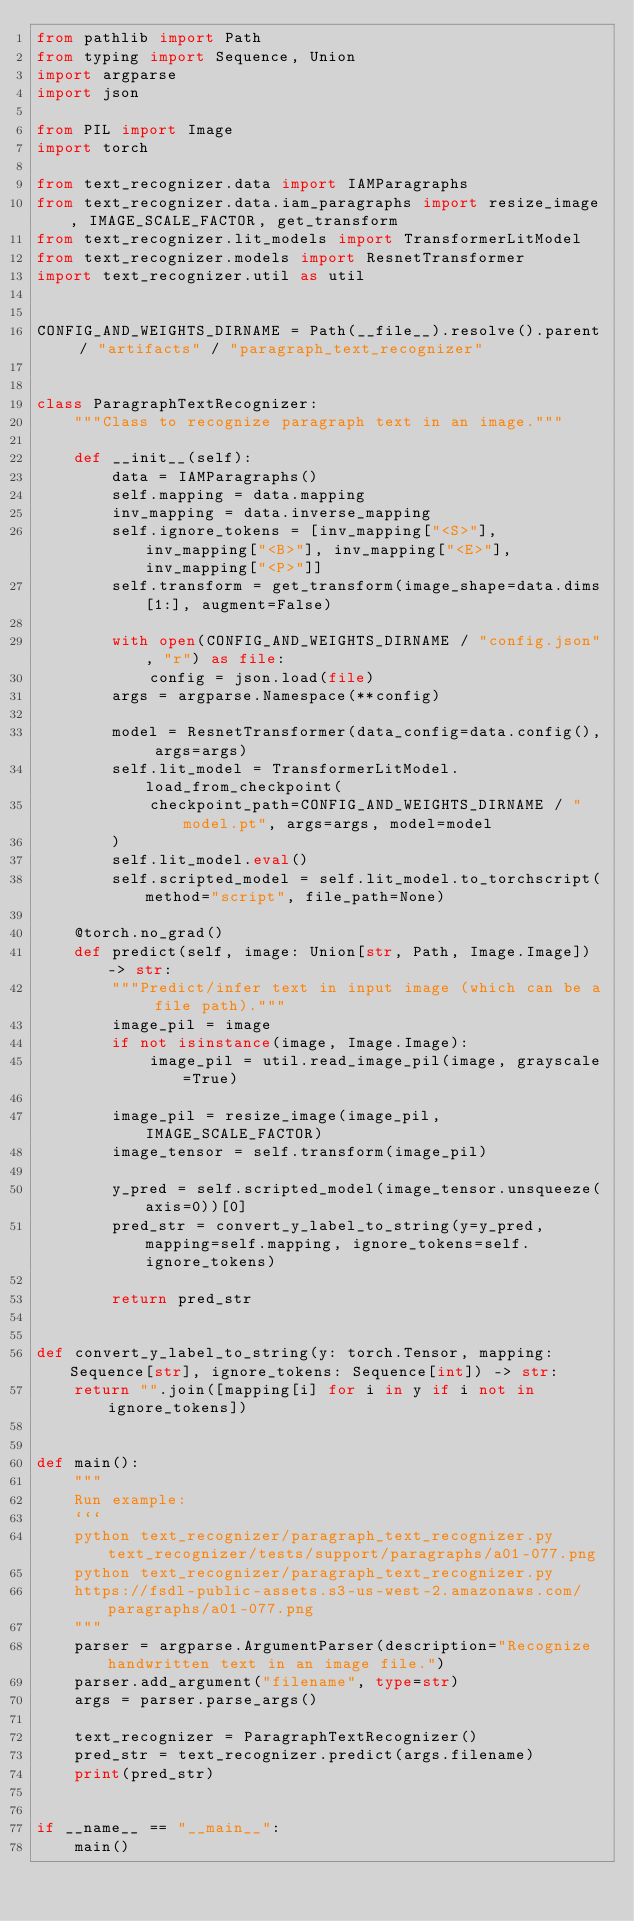<code> <loc_0><loc_0><loc_500><loc_500><_Python_>from pathlib import Path
from typing import Sequence, Union
import argparse
import json

from PIL import Image
import torch

from text_recognizer.data import IAMParagraphs
from text_recognizer.data.iam_paragraphs import resize_image, IMAGE_SCALE_FACTOR, get_transform
from text_recognizer.lit_models import TransformerLitModel
from text_recognizer.models import ResnetTransformer
import text_recognizer.util as util


CONFIG_AND_WEIGHTS_DIRNAME = Path(__file__).resolve().parent / "artifacts" / "paragraph_text_recognizer"


class ParagraphTextRecognizer:
    """Class to recognize paragraph text in an image."""

    def __init__(self):
        data = IAMParagraphs()
        self.mapping = data.mapping
        inv_mapping = data.inverse_mapping
        self.ignore_tokens = [inv_mapping["<S>"], inv_mapping["<B>"], inv_mapping["<E>"], inv_mapping["<P>"]]
        self.transform = get_transform(image_shape=data.dims[1:], augment=False)

        with open(CONFIG_AND_WEIGHTS_DIRNAME / "config.json", "r") as file:
            config = json.load(file)
        args = argparse.Namespace(**config)

        model = ResnetTransformer(data_config=data.config(), args=args)
        self.lit_model = TransformerLitModel.load_from_checkpoint(
            checkpoint_path=CONFIG_AND_WEIGHTS_DIRNAME / "model.pt", args=args, model=model
        )
        self.lit_model.eval()
        self.scripted_model = self.lit_model.to_torchscript(method="script", file_path=None)

    @torch.no_grad()
    def predict(self, image: Union[str, Path, Image.Image]) -> str:
        """Predict/infer text in input image (which can be a file path)."""
        image_pil = image
        if not isinstance(image, Image.Image):
            image_pil = util.read_image_pil(image, grayscale=True)

        image_pil = resize_image(image_pil, IMAGE_SCALE_FACTOR)
        image_tensor = self.transform(image_pil)

        y_pred = self.scripted_model(image_tensor.unsqueeze(axis=0))[0]
        pred_str = convert_y_label_to_string(y=y_pred, mapping=self.mapping, ignore_tokens=self.ignore_tokens)

        return pred_str


def convert_y_label_to_string(y: torch.Tensor, mapping: Sequence[str], ignore_tokens: Sequence[int]) -> str:
    return "".join([mapping[i] for i in y if i not in ignore_tokens])


def main():
    """
    Run example:
    ```
    python text_recognizer/paragraph_text_recognizer.py text_recognizer/tests/support/paragraphs/a01-077.png
    python text_recognizer/paragraph_text_recognizer.py
    https://fsdl-public-assets.s3-us-west-2.amazonaws.com/paragraphs/a01-077.png
    """
    parser = argparse.ArgumentParser(description="Recognize handwritten text in an image file.")
    parser.add_argument("filename", type=str)
    args = parser.parse_args()

    text_recognizer = ParagraphTextRecognizer()
    pred_str = text_recognizer.predict(args.filename)
    print(pred_str)


if __name__ == "__main__":
    main()
</code> 